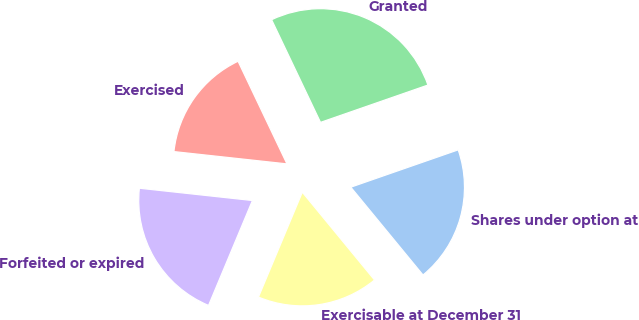Convert chart to OTSL. <chart><loc_0><loc_0><loc_500><loc_500><pie_chart><fcel>Shares under option at<fcel>Granted<fcel>Exercised<fcel>Forfeited or expired<fcel>Exercisable at December 31<nl><fcel>19.37%<fcel>26.75%<fcel>16.2%<fcel>20.42%<fcel>17.26%<nl></chart> 